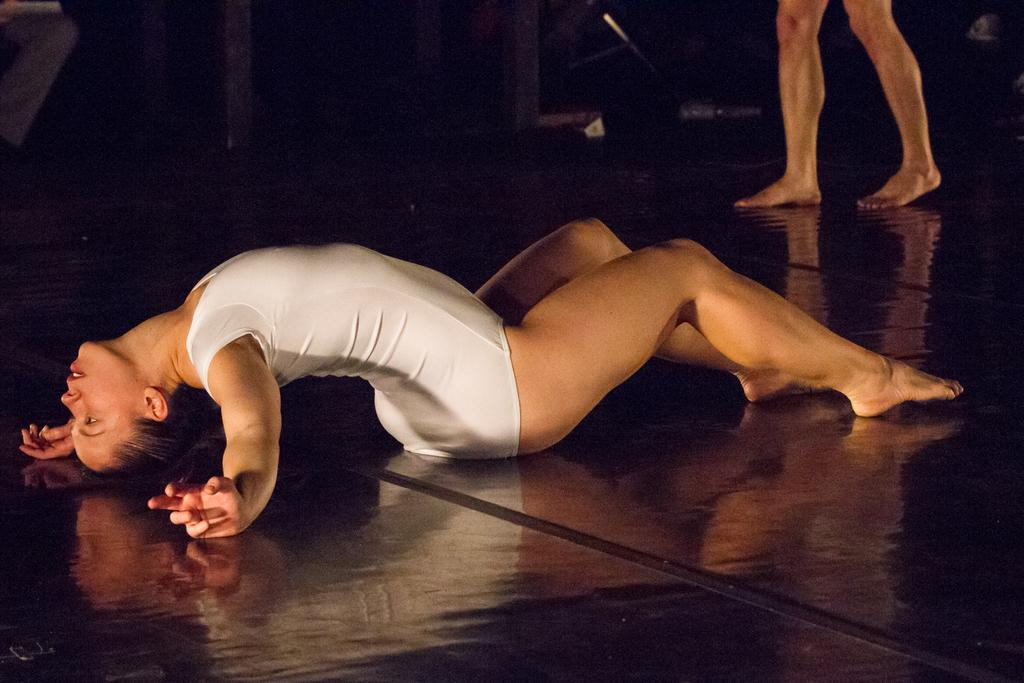Who is the main subject in the image? There is a woman in the center of the image. What is the woman doing in the image? The woman is playing. What can be seen at the bottom of the image? There is a floor visible at the bottom of the image. Can you describe the background of the image? There is another person's legs visible in the background, along with some objects. Where is the faucet located in the image? There is no faucet present in the image. What type of cup is being used by the woman in the image? There is no cup visible in the image; the woman is playing. 